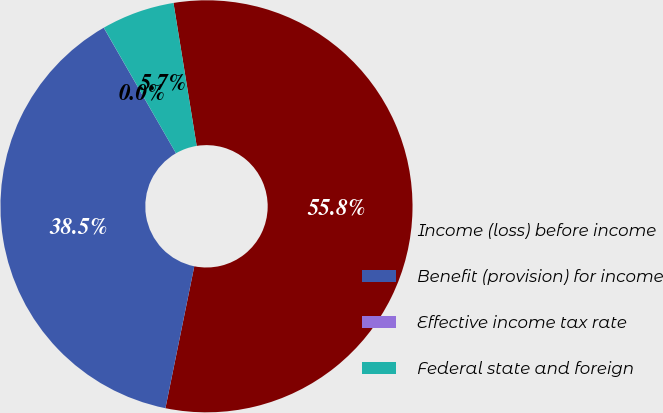Convert chart to OTSL. <chart><loc_0><loc_0><loc_500><loc_500><pie_chart><fcel>Income (loss) before income<fcel>Benefit (provision) for income<fcel>Effective income tax rate<fcel>Federal state and foreign<nl><fcel>55.76%<fcel>38.5%<fcel>0.01%<fcel>5.74%<nl></chart> 